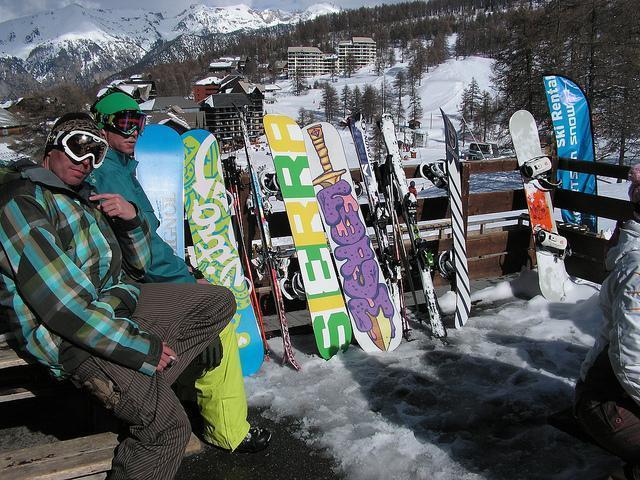How many snowboards are visible?
Give a very brief answer. 6. How many ski can be seen?
Give a very brief answer. 3. How many people can be seen?
Give a very brief answer. 3. 